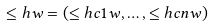Convert formula to latex. <formula><loc_0><loc_0><loc_500><loc_500>\leq h { w } = ( \leq h c { 1 } { w } , \dots , \leq h c { n } { w } )</formula> 